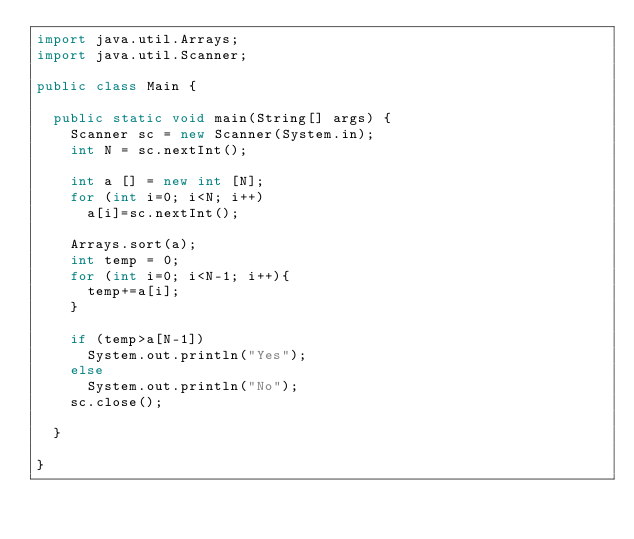<code> <loc_0><loc_0><loc_500><loc_500><_Java_>import java.util.Arrays;
import java.util.Scanner;

public class Main {

	public static void main(String[] args) {
		Scanner sc = new Scanner(System.in);
		int N = sc.nextInt();
		
		int a [] = new int [N];
		for (int i=0; i<N; i++)
			a[i]=sc.nextInt();
		
		Arrays.sort(a);
		int temp = 0;
		for (int i=0; i<N-1; i++){
			temp+=a[i];
		}
		
		if (temp>a[N-1])
			System.out.println("Yes");
		else
			System.out.println("No");
		sc.close();

	}

}
</code> 